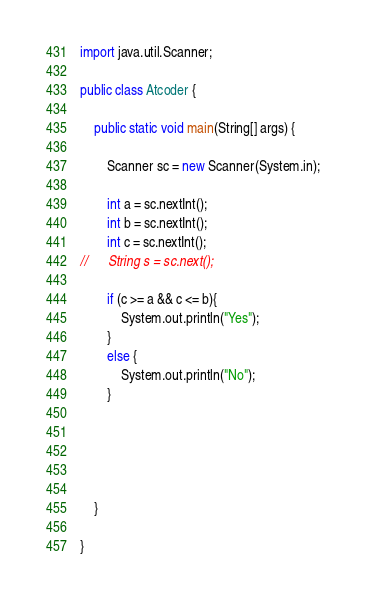Convert code to text. <code><loc_0><loc_0><loc_500><loc_500><_Java_>import java.util.Scanner;

public class Atcoder {

	public static void main(String[] args) {
		
		Scanner sc = new Scanner(System.in);
		
		int a = sc.nextInt();
		int b = sc.nextInt();
		int c = sc.nextInt();
//		String s = sc.next();
		
		if (c >= a && c <= b){
			System.out.println("Yes");
		}
		else {
			System.out.println("No");
		}
		
		
		
		

	}

}
</code> 